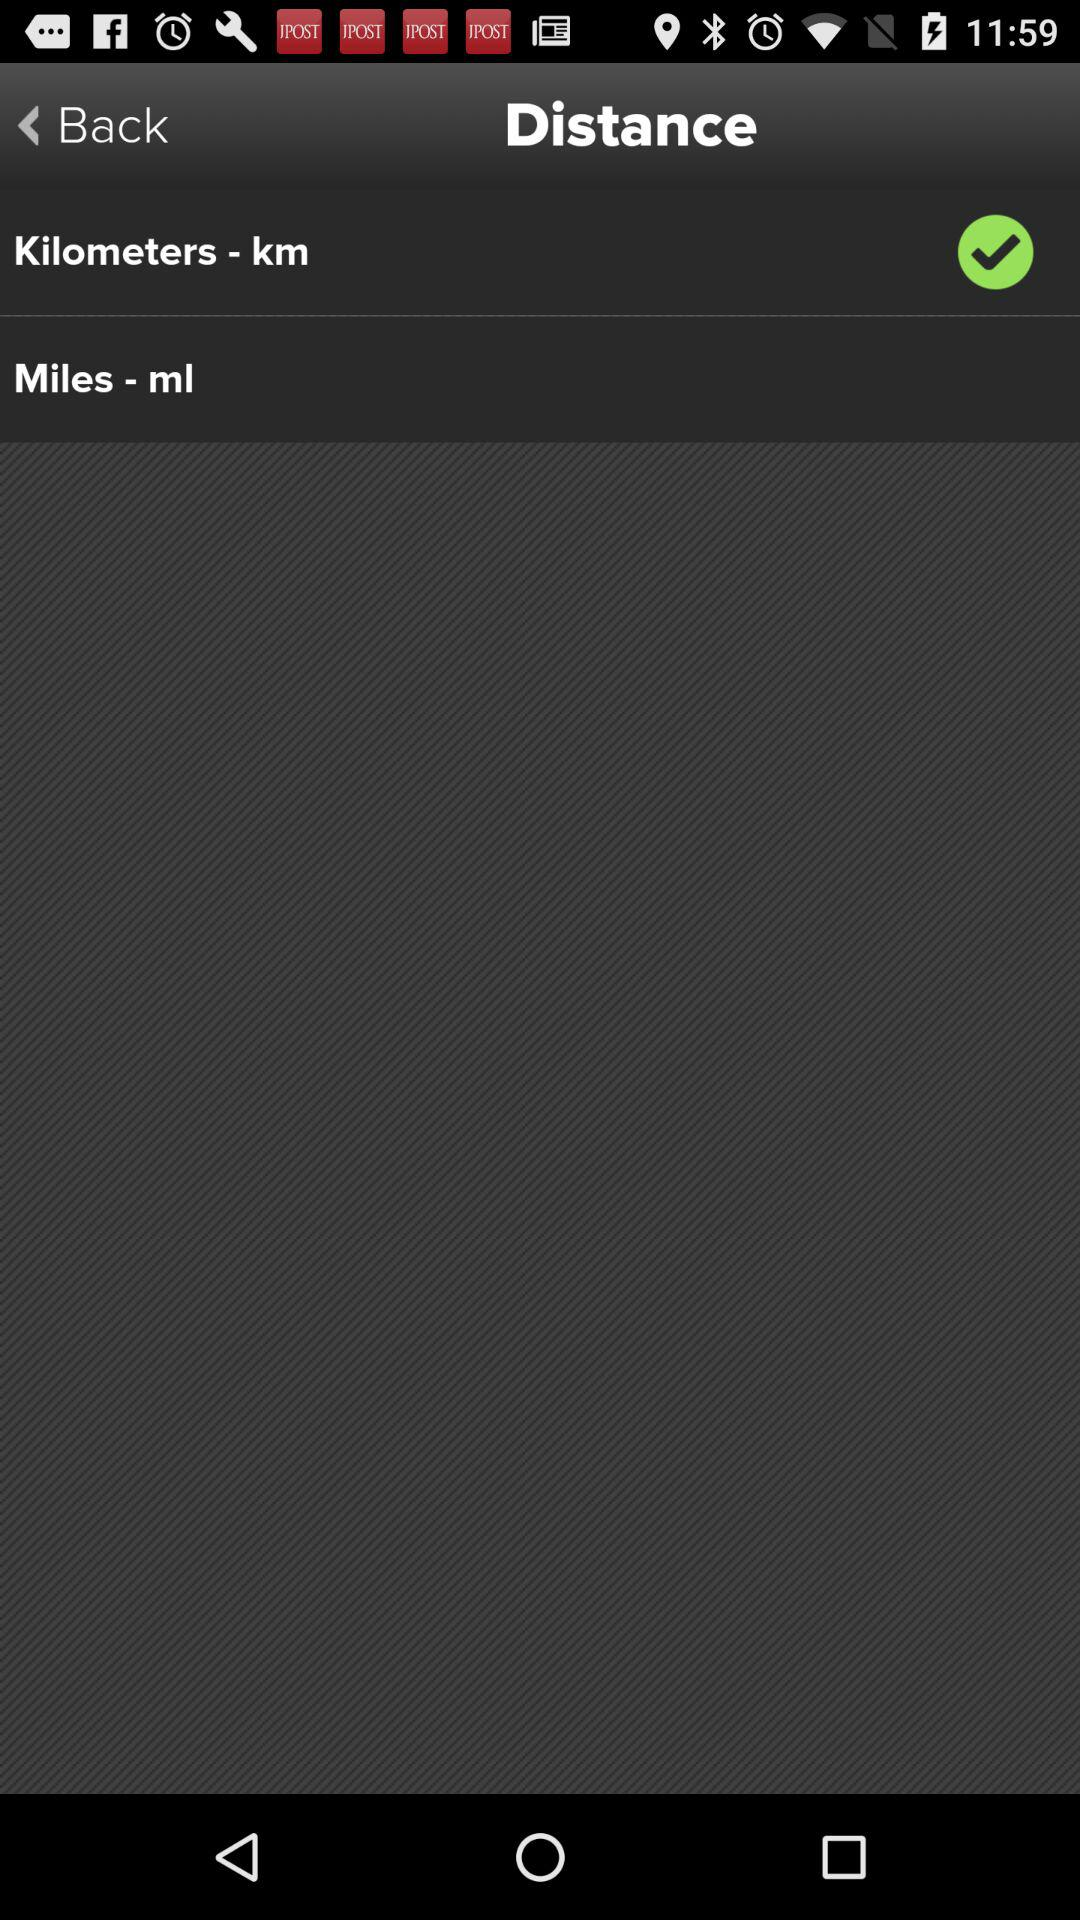What is the selected type of unit of distance? The selected type of unit of distance is kilometers. 